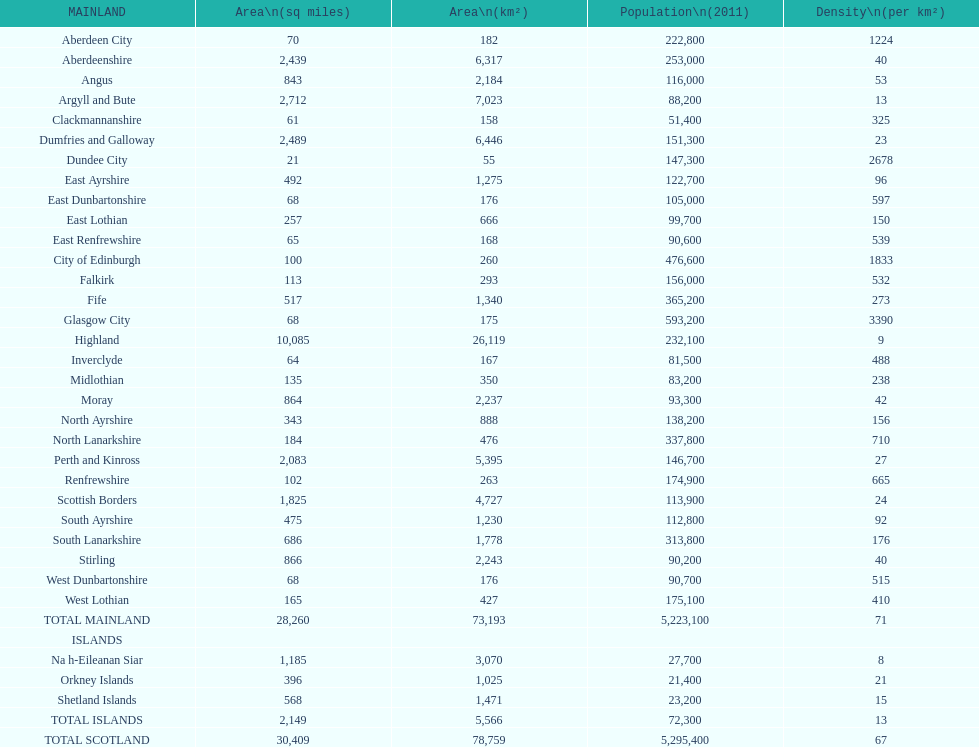What number of mainlands have populations under 100,000? 9. 